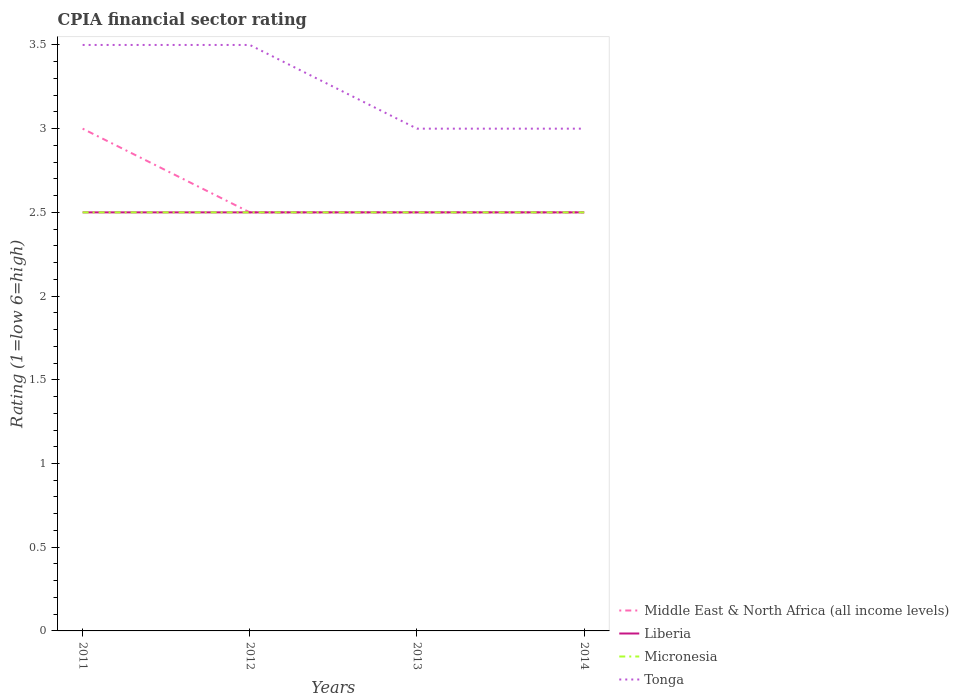Across all years, what is the maximum CPIA rating in Liberia?
Ensure brevity in your answer.  2.5. In which year was the CPIA rating in Liberia maximum?
Offer a very short reply. 2011. What is the total CPIA rating in Middle East & North Africa (all income levels) in the graph?
Your answer should be very brief. 0.5. What is the difference between the highest and the second highest CPIA rating in Tonga?
Provide a short and direct response. 0.5. How many lines are there?
Your answer should be compact. 4. What is the difference between two consecutive major ticks on the Y-axis?
Give a very brief answer. 0.5. Does the graph contain any zero values?
Keep it short and to the point. No. Does the graph contain grids?
Keep it short and to the point. No. Where does the legend appear in the graph?
Make the answer very short. Bottom right. How many legend labels are there?
Offer a terse response. 4. What is the title of the graph?
Ensure brevity in your answer.  CPIA financial sector rating. What is the label or title of the X-axis?
Your answer should be compact. Years. What is the label or title of the Y-axis?
Keep it short and to the point. Rating (1=low 6=high). What is the Rating (1=low 6=high) in Liberia in 2011?
Ensure brevity in your answer.  2.5. What is the Rating (1=low 6=high) in Micronesia in 2011?
Provide a short and direct response. 2.5. What is the Rating (1=low 6=high) in Middle East & North Africa (all income levels) in 2012?
Offer a very short reply. 2.5. What is the Rating (1=low 6=high) of Liberia in 2012?
Your answer should be very brief. 2.5. What is the Rating (1=low 6=high) of Tonga in 2012?
Give a very brief answer. 3.5. What is the Rating (1=low 6=high) of Micronesia in 2013?
Provide a succinct answer. 2.5. What is the Rating (1=low 6=high) of Middle East & North Africa (all income levels) in 2014?
Your answer should be compact. 2.5. What is the Rating (1=low 6=high) of Micronesia in 2014?
Keep it short and to the point. 2.5. What is the Rating (1=low 6=high) of Tonga in 2014?
Provide a succinct answer. 3. Across all years, what is the maximum Rating (1=low 6=high) in Middle East & North Africa (all income levels)?
Your answer should be very brief. 3. Across all years, what is the minimum Rating (1=low 6=high) of Middle East & North Africa (all income levels)?
Offer a very short reply. 2.5. Across all years, what is the minimum Rating (1=low 6=high) of Tonga?
Make the answer very short. 3. What is the total Rating (1=low 6=high) of Liberia in the graph?
Offer a very short reply. 10. What is the total Rating (1=low 6=high) in Micronesia in the graph?
Offer a very short reply. 10. What is the difference between the Rating (1=low 6=high) in Liberia in 2011 and that in 2012?
Keep it short and to the point. 0. What is the difference between the Rating (1=low 6=high) in Micronesia in 2011 and that in 2012?
Ensure brevity in your answer.  0. What is the difference between the Rating (1=low 6=high) in Liberia in 2011 and that in 2013?
Offer a terse response. 0. What is the difference between the Rating (1=low 6=high) in Tonga in 2011 and that in 2013?
Ensure brevity in your answer.  0.5. What is the difference between the Rating (1=low 6=high) in Liberia in 2011 and that in 2014?
Ensure brevity in your answer.  0. What is the difference between the Rating (1=low 6=high) of Micronesia in 2011 and that in 2014?
Your response must be concise. 0. What is the difference between the Rating (1=low 6=high) in Tonga in 2011 and that in 2014?
Your answer should be very brief. 0.5. What is the difference between the Rating (1=low 6=high) of Middle East & North Africa (all income levels) in 2012 and that in 2013?
Make the answer very short. 0. What is the difference between the Rating (1=low 6=high) in Liberia in 2012 and that in 2013?
Your answer should be compact. 0. What is the difference between the Rating (1=low 6=high) in Liberia in 2012 and that in 2014?
Provide a succinct answer. 0. What is the difference between the Rating (1=low 6=high) of Micronesia in 2012 and that in 2014?
Make the answer very short. 0. What is the difference between the Rating (1=low 6=high) of Tonga in 2012 and that in 2014?
Make the answer very short. 0.5. What is the difference between the Rating (1=low 6=high) of Liberia in 2013 and that in 2014?
Ensure brevity in your answer.  0. What is the difference between the Rating (1=low 6=high) of Middle East & North Africa (all income levels) in 2011 and the Rating (1=low 6=high) of Liberia in 2012?
Offer a terse response. 0.5. What is the difference between the Rating (1=low 6=high) in Middle East & North Africa (all income levels) in 2011 and the Rating (1=low 6=high) in Tonga in 2012?
Your answer should be compact. -0.5. What is the difference between the Rating (1=low 6=high) of Liberia in 2011 and the Rating (1=low 6=high) of Tonga in 2012?
Offer a very short reply. -1. What is the difference between the Rating (1=low 6=high) in Micronesia in 2011 and the Rating (1=low 6=high) in Tonga in 2012?
Keep it short and to the point. -1. What is the difference between the Rating (1=low 6=high) in Middle East & North Africa (all income levels) in 2011 and the Rating (1=low 6=high) in Liberia in 2013?
Give a very brief answer. 0.5. What is the difference between the Rating (1=low 6=high) in Liberia in 2011 and the Rating (1=low 6=high) in Tonga in 2013?
Provide a short and direct response. -0.5. What is the difference between the Rating (1=low 6=high) of Middle East & North Africa (all income levels) in 2011 and the Rating (1=low 6=high) of Micronesia in 2014?
Provide a short and direct response. 0.5. What is the difference between the Rating (1=low 6=high) of Liberia in 2011 and the Rating (1=low 6=high) of Micronesia in 2014?
Keep it short and to the point. 0. What is the difference between the Rating (1=low 6=high) in Liberia in 2011 and the Rating (1=low 6=high) in Tonga in 2014?
Provide a short and direct response. -0.5. What is the difference between the Rating (1=low 6=high) in Micronesia in 2011 and the Rating (1=low 6=high) in Tonga in 2014?
Give a very brief answer. -0.5. What is the difference between the Rating (1=low 6=high) of Middle East & North Africa (all income levels) in 2012 and the Rating (1=low 6=high) of Liberia in 2013?
Offer a very short reply. 0. What is the difference between the Rating (1=low 6=high) in Middle East & North Africa (all income levels) in 2012 and the Rating (1=low 6=high) in Micronesia in 2013?
Give a very brief answer. 0. What is the difference between the Rating (1=low 6=high) in Middle East & North Africa (all income levels) in 2012 and the Rating (1=low 6=high) in Tonga in 2013?
Your answer should be compact. -0.5. What is the difference between the Rating (1=low 6=high) of Liberia in 2012 and the Rating (1=low 6=high) of Micronesia in 2013?
Provide a short and direct response. 0. What is the difference between the Rating (1=low 6=high) of Liberia in 2012 and the Rating (1=low 6=high) of Tonga in 2013?
Provide a short and direct response. -0.5. What is the difference between the Rating (1=low 6=high) in Micronesia in 2012 and the Rating (1=low 6=high) in Tonga in 2013?
Give a very brief answer. -0.5. What is the difference between the Rating (1=low 6=high) of Middle East & North Africa (all income levels) in 2012 and the Rating (1=low 6=high) of Liberia in 2014?
Give a very brief answer. 0. What is the difference between the Rating (1=low 6=high) of Middle East & North Africa (all income levels) in 2012 and the Rating (1=low 6=high) of Micronesia in 2014?
Your response must be concise. 0. What is the difference between the Rating (1=low 6=high) of Middle East & North Africa (all income levels) in 2012 and the Rating (1=low 6=high) of Tonga in 2014?
Give a very brief answer. -0.5. What is the difference between the Rating (1=low 6=high) of Liberia in 2012 and the Rating (1=low 6=high) of Tonga in 2014?
Make the answer very short. -0.5. What is the difference between the Rating (1=low 6=high) in Middle East & North Africa (all income levels) in 2013 and the Rating (1=low 6=high) in Liberia in 2014?
Your answer should be very brief. 0. What is the difference between the Rating (1=low 6=high) of Middle East & North Africa (all income levels) in 2013 and the Rating (1=low 6=high) of Micronesia in 2014?
Provide a short and direct response. 0. What is the difference between the Rating (1=low 6=high) in Micronesia in 2013 and the Rating (1=low 6=high) in Tonga in 2014?
Keep it short and to the point. -0.5. What is the average Rating (1=low 6=high) of Middle East & North Africa (all income levels) per year?
Ensure brevity in your answer.  2.62. What is the average Rating (1=low 6=high) of Tonga per year?
Your response must be concise. 3.25. In the year 2011, what is the difference between the Rating (1=low 6=high) in Middle East & North Africa (all income levels) and Rating (1=low 6=high) in Tonga?
Offer a terse response. -0.5. In the year 2011, what is the difference between the Rating (1=low 6=high) of Liberia and Rating (1=low 6=high) of Micronesia?
Keep it short and to the point. 0. In the year 2011, what is the difference between the Rating (1=low 6=high) in Micronesia and Rating (1=low 6=high) in Tonga?
Offer a terse response. -1. In the year 2012, what is the difference between the Rating (1=low 6=high) of Middle East & North Africa (all income levels) and Rating (1=low 6=high) of Liberia?
Provide a short and direct response. 0. In the year 2013, what is the difference between the Rating (1=low 6=high) in Liberia and Rating (1=low 6=high) in Tonga?
Your response must be concise. -0.5. In the year 2014, what is the difference between the Rating (1=low 6=high) of Middle East & North Africa (all income levels) and Rating (1=low 6=high) of Liberia?
Your answer should be compact. 0. In the year 2014, what is the difference between the Rating (1=low 6=high) in Middle East & North Africa (all income levels) and Rating (1=low 6=high) in Micronesia?
Give a very brief answer. 0. In the year 2014, what is the difference between the Rating (1=low 6=high) in Micronesia and Rating (1=low 6=high) in Tonga?
Your answer should be very brief. -0.5. What is the ratio of the Rating (1=low 6=high) of Middle East & North Africa (all income levels) in 2011 to that in 2012?
Keep it short and to the point. 1.2. What is the ratio of the Rating (1=low 6=high) of Liberia in 2011 to that in 2012?
Give a very brief answer. 1. What is the ratio of the Rating (1=low 6=high) in Tonga in 2011 to that in 2012?
Your answer should be compact. 1. What is the ratio of the Rating (1=low 6=high) of Middle East & North Africa (all income levels) in 2011 to that in 2013?
Make the answer very short. 1.2. What is the ratio of the Rating (1=low 6=high) of Micronesia in 2011 to that in 2013?
Keep it short and to the point. 1. What is the ratio of the Rating (1=low 6=high) of Middle East & North Africa (all income levels) in 2012 to that in 2013?
Offer a terse response. 1. What is the ratio of the Rating (1=low 6=high) in Liberia in 2012 to that in 2013?
Give a very brief answer. 1. What is the ratio of the Rating (1=low 6=high) in Middle East & North Africa (all income levels) in 2012 to that in 2014?
Offer a very short reply. 1. What is the ratio of the Rating (1=low 6=high) in Micronesia in 2012 to that in 2014?
Provide a succinct answer. 1. What is the ratio of the Rating (1=low 6=high) in Tonga in 2012 to that in 2014?
Your answer should be compact. 1.17. What is the ratio of the Rating (1=low 6=high) in Liberia in 2013 to that in 2014?
Offer a very short reply. 1. What is the ratio of the Rating (1=low 6=high) in Micronesia in 2013 to that in 2014?
Your answer should be compact. 1. What is the difference between the highest and the second highest Rating (1=low 6=high) of Middle East & North Africa (all income levels)?
Keep it short and to the point. 0.5. What is the difference between the highest and the second highest Rating (1=low 6=high) in Liberia?
Keep it short and to the point. 0. What is the difference between the highest and the second highest Rating (1=low 6=high) in Micronesia?
Provide a succinct answer. 0. What is the difference between the highest and the second highest Rating (1=low 6=high) of Tonga?
Your answer should be compact. 0. 